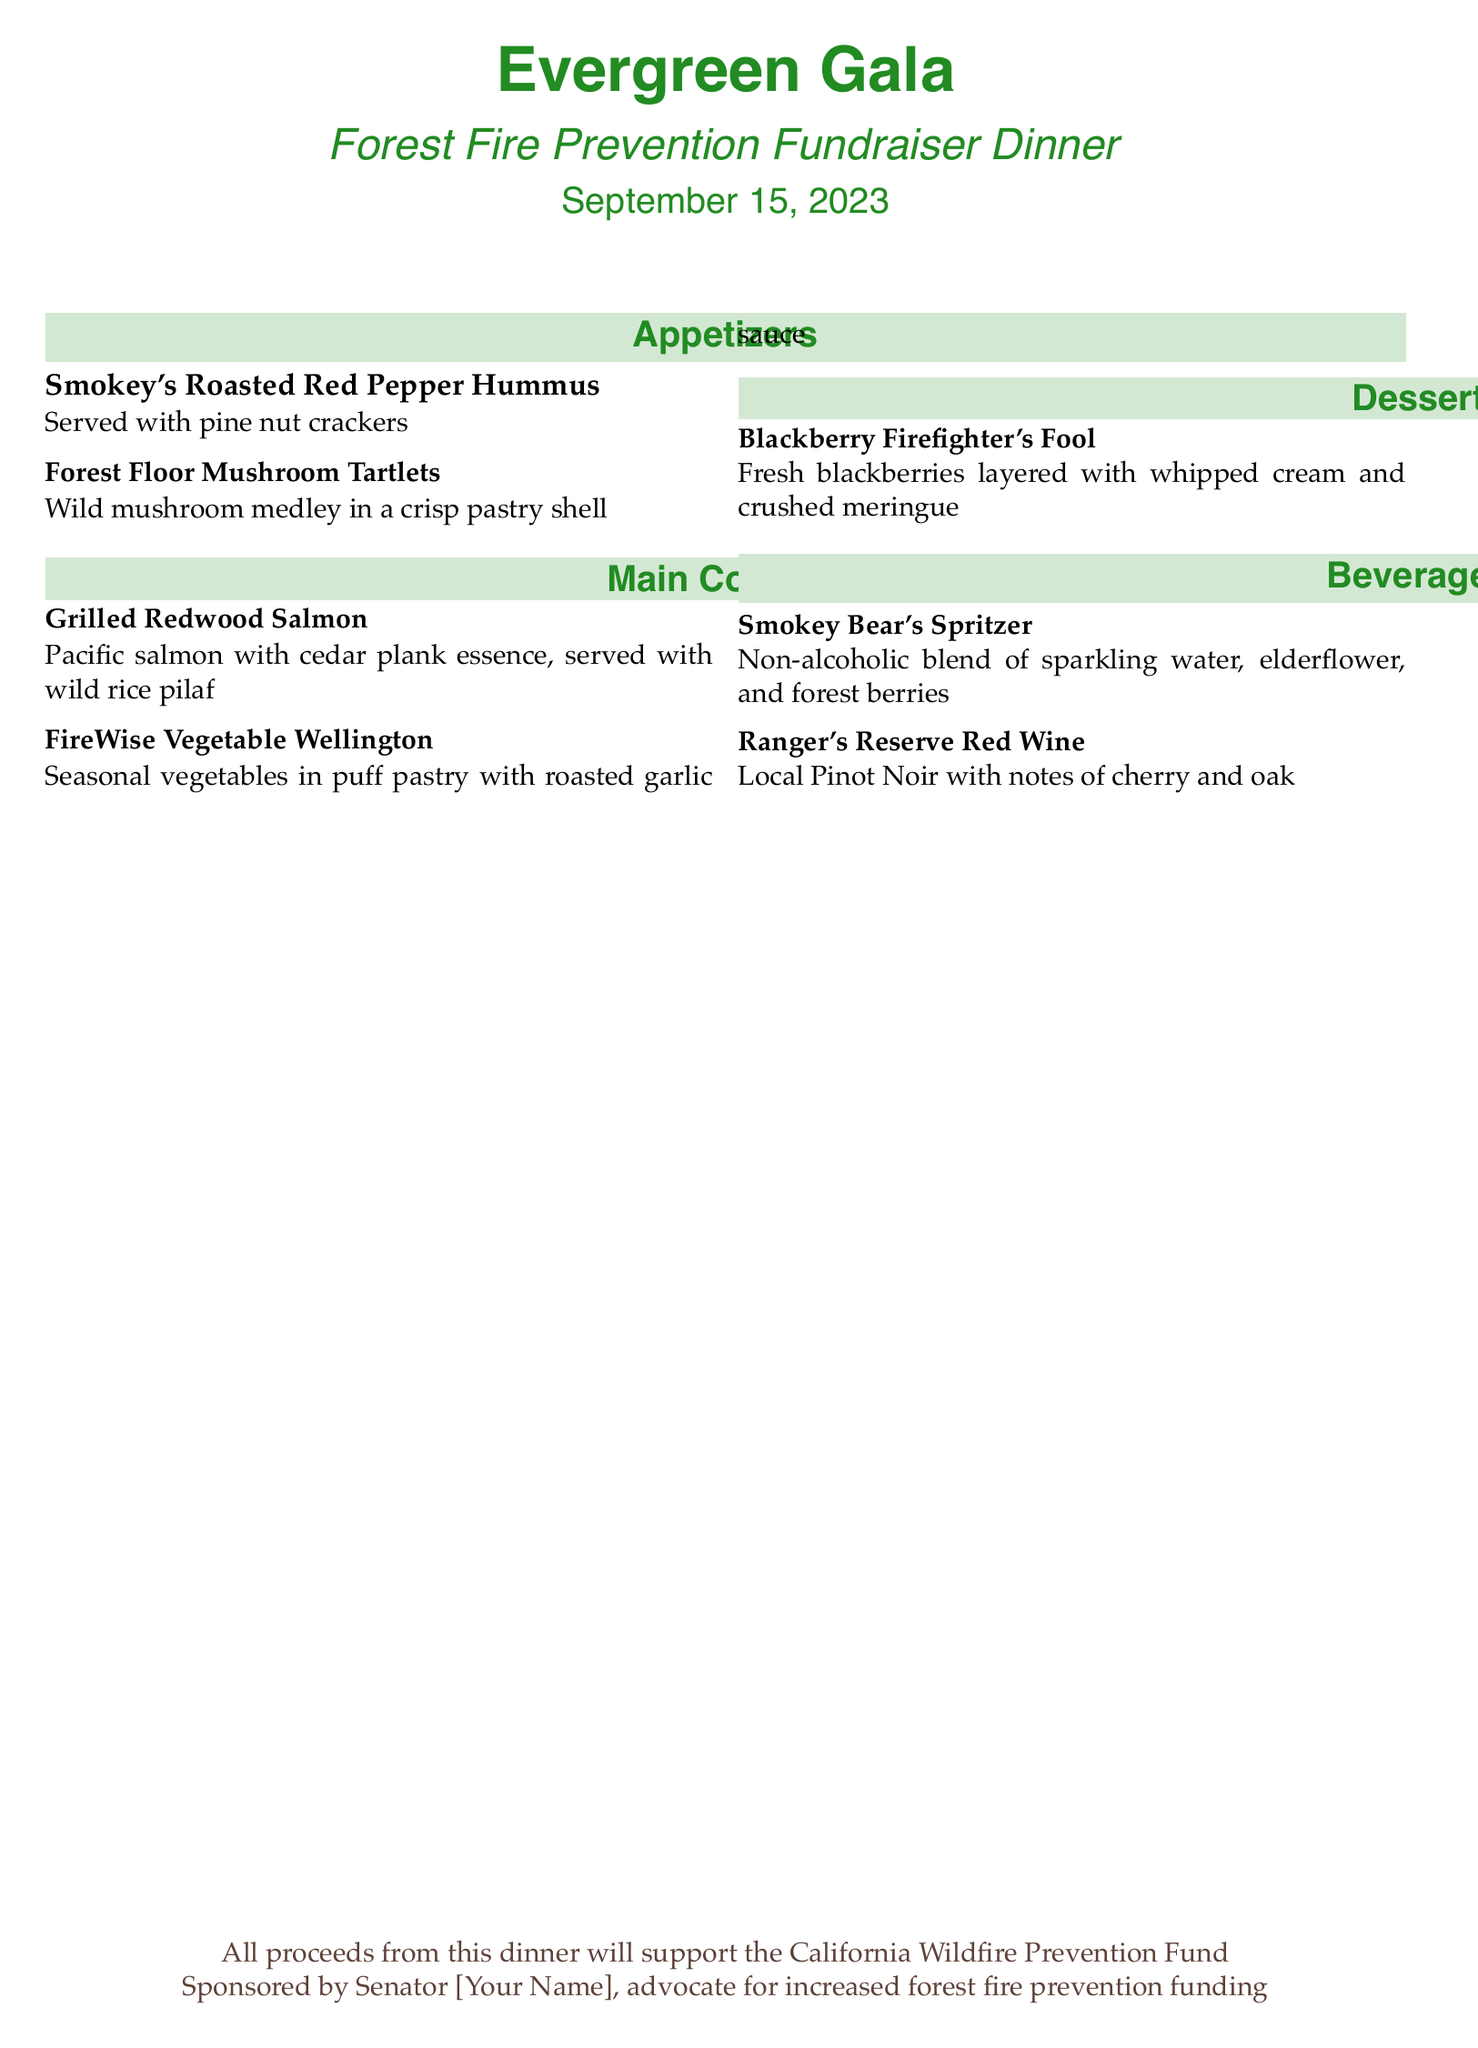What is the date of the dinner? The date of the dinner is mentioned in the title section of the document.
Answer: September 15, 2023 What is the name of the fundraiser? The name of the fundraiser is stated at the top of the document as the event title.
Answer: Evergreen Gala How many main courses are listed? The number of main courses can be counted from the section titled "Main Courses".
Answer: 2 What is the first item on the appetizer menu? The first item is the initial entry listed under the "Appetizers" section.
Answer: Smokey's Roasted Red Pepper Hummus What beverage is non-alcoholic? The non-alcoholic beverage is specified in the "Beverages" section.
Answer: Smokey Bear's Spritzer What is the dessert's main fruit ingredient? The main fruit ingredient of the dessert is identified in its description.
Answer: Blackberries Which course includes seasonal vegetables? The course containing seasonal vegetables is referenced in the description of one of the main dishes.
Answer: Main Courses Who sponsored the event? The document mentions the sponsor in the footer section.
Answer: Senator [Your Name] What will the proceeds from the dinner support? The purpose of the proceeds is detailed in the bottom section of the document.
Answer: California Wildfire Prevention Fund 